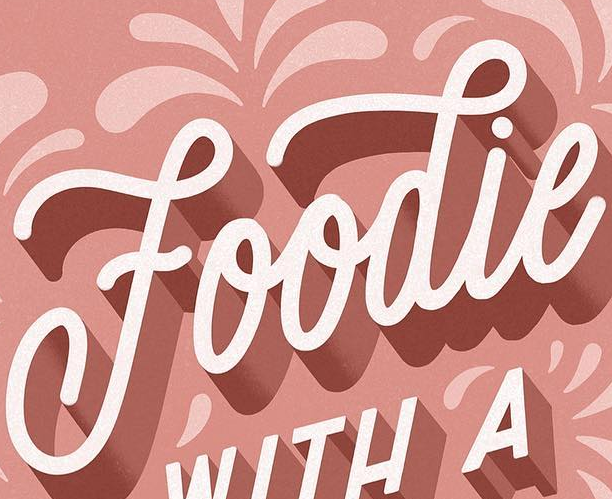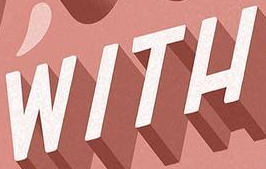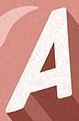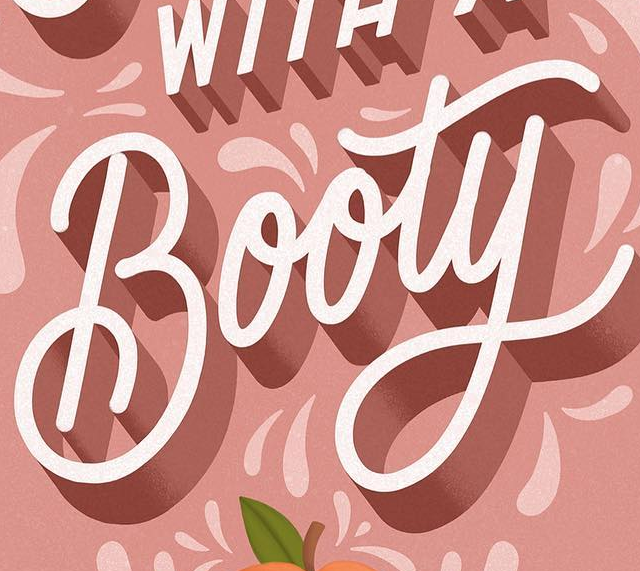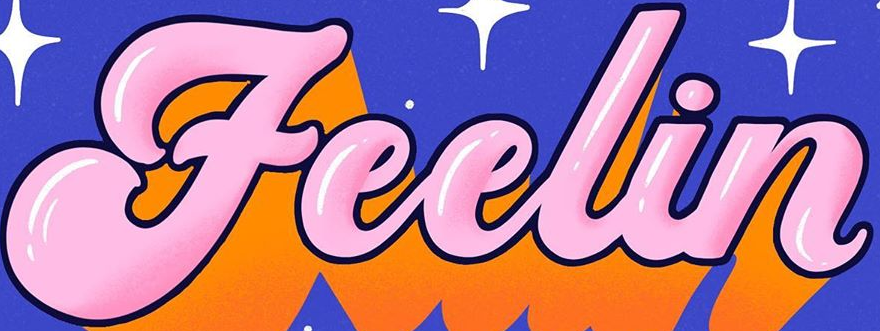Read the text content from these images in order, separated by a semicolon. Foodie; WITH; A; Booty; Feelin 